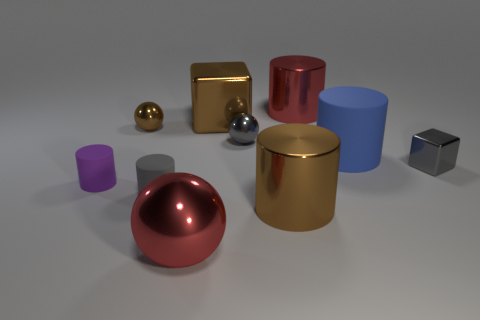There is a gray object that is left of the red metallic thing left of the large red metallic object that is behind the blue matte thing; what is it made of?
Give a very brief answer. Rubber. There is a purple rubber object; is it the same size as the gray shiny thing in front of the blue cylinder?
Ensure brevity in your answer.  Yes. What material is the small purple object that is the same shape as the blue object?
Your answer should be compact. Rubber. What size is the red metal cylinder that is right of the brown metallic object that is behind the small metallic object that is left of the brown block?
Make the answer very short. Large. Do the brown metallic sphere and the gray rubber cylinder have the same size?
Provide a short and direct response. Yes. The small cylinder that is on the right side of the matte object left of the tiny brown object is made of what material?
Your answer should be compact. Rubber. Is the shape of the large brown object that is behind the gray metallic block the same as the tiny gray shiny object right of the gray ball?
Your response must be concise. Yes. Is the number of large balls that are behind the red ball the same as the number of gray balls?
Keep it short and to the point. No. There is a gray metallic object behind the blue rubber thing; are there any metal balls on the left side of it?
Your answer should be very brief. Yes. Is there any other thing that is the same color as the large rubber cylinder?
Give a very brief answer. No. 